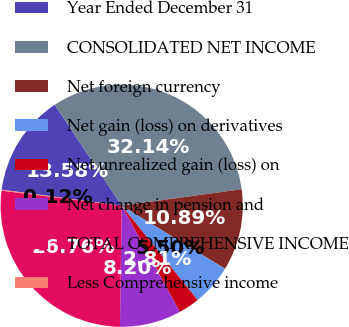Convert chart. <chart><loc_0><loc_0><loc_500><loc_500><pie_chart><fcel>Year Ended December 31<fcel>CONSOLIDATED NET INCOME<fcel>Net foreign currency<fcel>Net gain (loss) on derivatives<fcel>Net unrealized gain (loss) on<fcel>Net change in pension and<fcel>TOTAL COMPREHENSIVE INCOME<fcel>Less Comprehensive income<nl><fcel>13.58%<fcel>32.14%<fcel>10.89%<fcel>5.5%<fcel>2.81%<fcel>8.2%<fcel>26.76%<fcel>0.12%<nl></chart> 